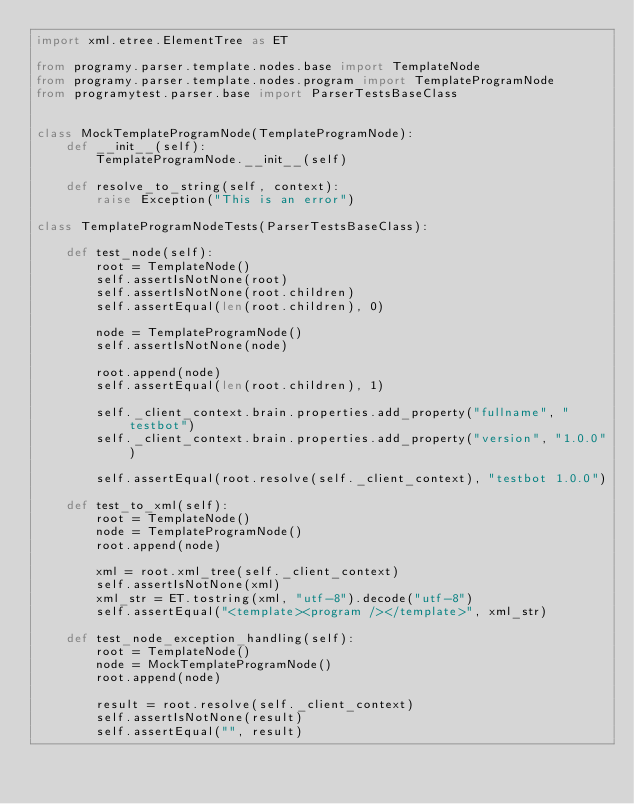Convert code to text. <code><loc_0><loc_0><loc_500><loc_500><_Python_>import xml.etree.ElementTree as ET

from programy.parser.template.nodes.base import TemplateNode
from programy.parser.template.nodes.program import TemplateProgramNode
from programytest.parser.base import ParserTestsBaseClass


class MockTemplateProgramNode(TemplateProgramNode):
    def __init__(self):
        TemplateProgramNode.__init__(self)

    def resolve_to_string(self, context):
        raise Exception("This is an error")

class TemplateProgramNodeTests(ParserTestsBaseClass):

    def test_node(self):
        root = TemplateNode()
        self.assertIsNotNone(root)
        self.assertIsNotNone(root.children)
        self.assertEqual(len(root.children), 0)

        node = TemplateProgramNode()
        self.assertIsNotNone(node)

        root.append(node)
        self.assertEqual(len(root.children), 1)

        self._client_context.brain.properties.add_property("fullname", "testbot")
        self._client_context.brain.properties.add_property("version", "1.0.0")

        self.assertEqual(root.resolve(self._client_context), "testbot 1.0.0")

    def test_to_xml(self):
        root = TemplateNode()
        node = TemplateProgramNode()
        root.append(node)

        xml = root.xml_tree(self._client_context)
        self.assertIsNotNone(xml)
        xml_str = ET.tostring(xml, "utf-8").decode("utf-8")
        self.assertEqual("<template><program /></template>", xml_str)

    def test_node_exception_handling(self):
        root = TemplateNode()
        node = MockTemplateProgramNode()
        root.append(node)

        result = root.resolve(self._client_context)
        self.assertIsNotNone(result)
        self.assertEqual("", result)</code> 